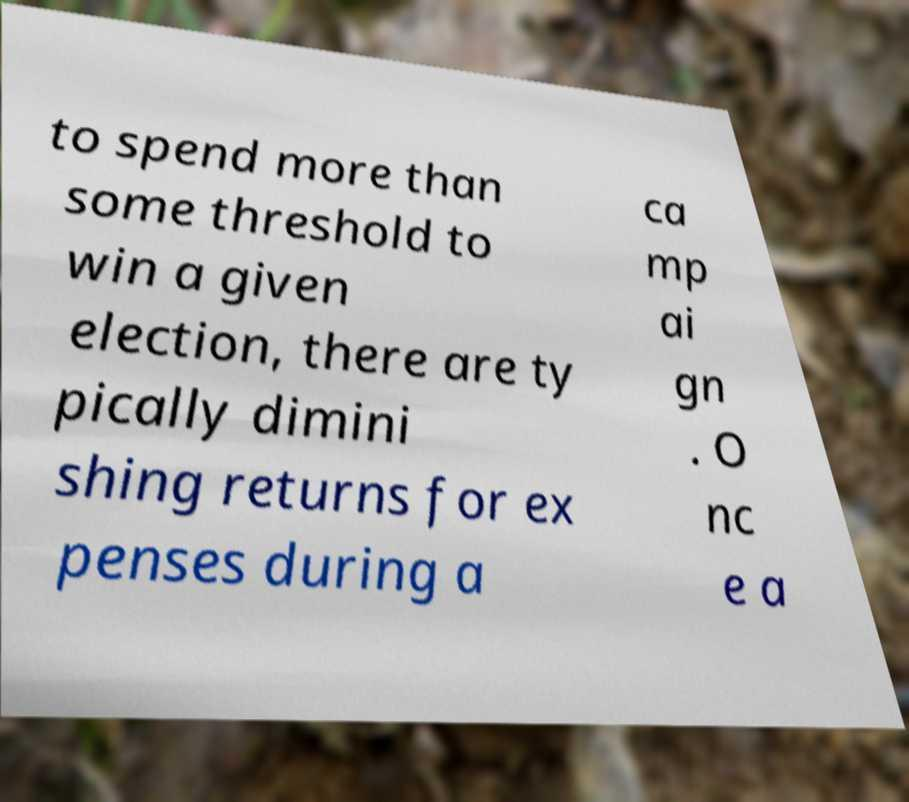There's text embedded in this image that I need extracted. Can you transcribe it verbatim? to spend more than some threshold to win a given election, there are ty pically dimini shing returns for ex penses during a ca mp ai gn . O nc e a 